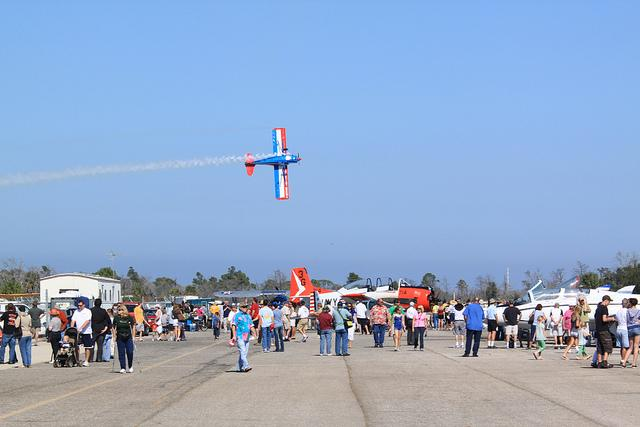Who will be riding those planes? pilots 